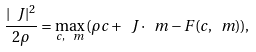Convert formula to latex. <formula><loc_0><loc_0><loc_500><loc_500>\frac { | \ J | ^ { 2 } } { 2 \rho } = \max _ { c , \, \ m } \, ( \rho c + \ J \cdot \ m - F ( c , \ m ) ) ,</formula> 